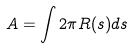<formula> <loc_0><loc_0><loc_500><loc_500>A = \int 2 \pi R ( s ) d s</formula> 